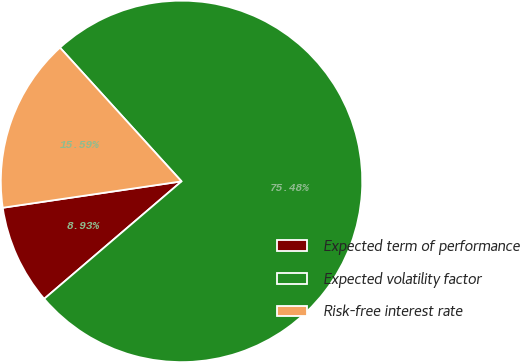<chart> <loc_0><loc_0><loc_500><loc_500><pie_chart><fcel>Expected term of performance<fcel>Expected volatility factor<fcel>Risk-free interest rate<nl><fcel>8.93%<fcel>75.48%<fcel>15.59%<nl></chart> 